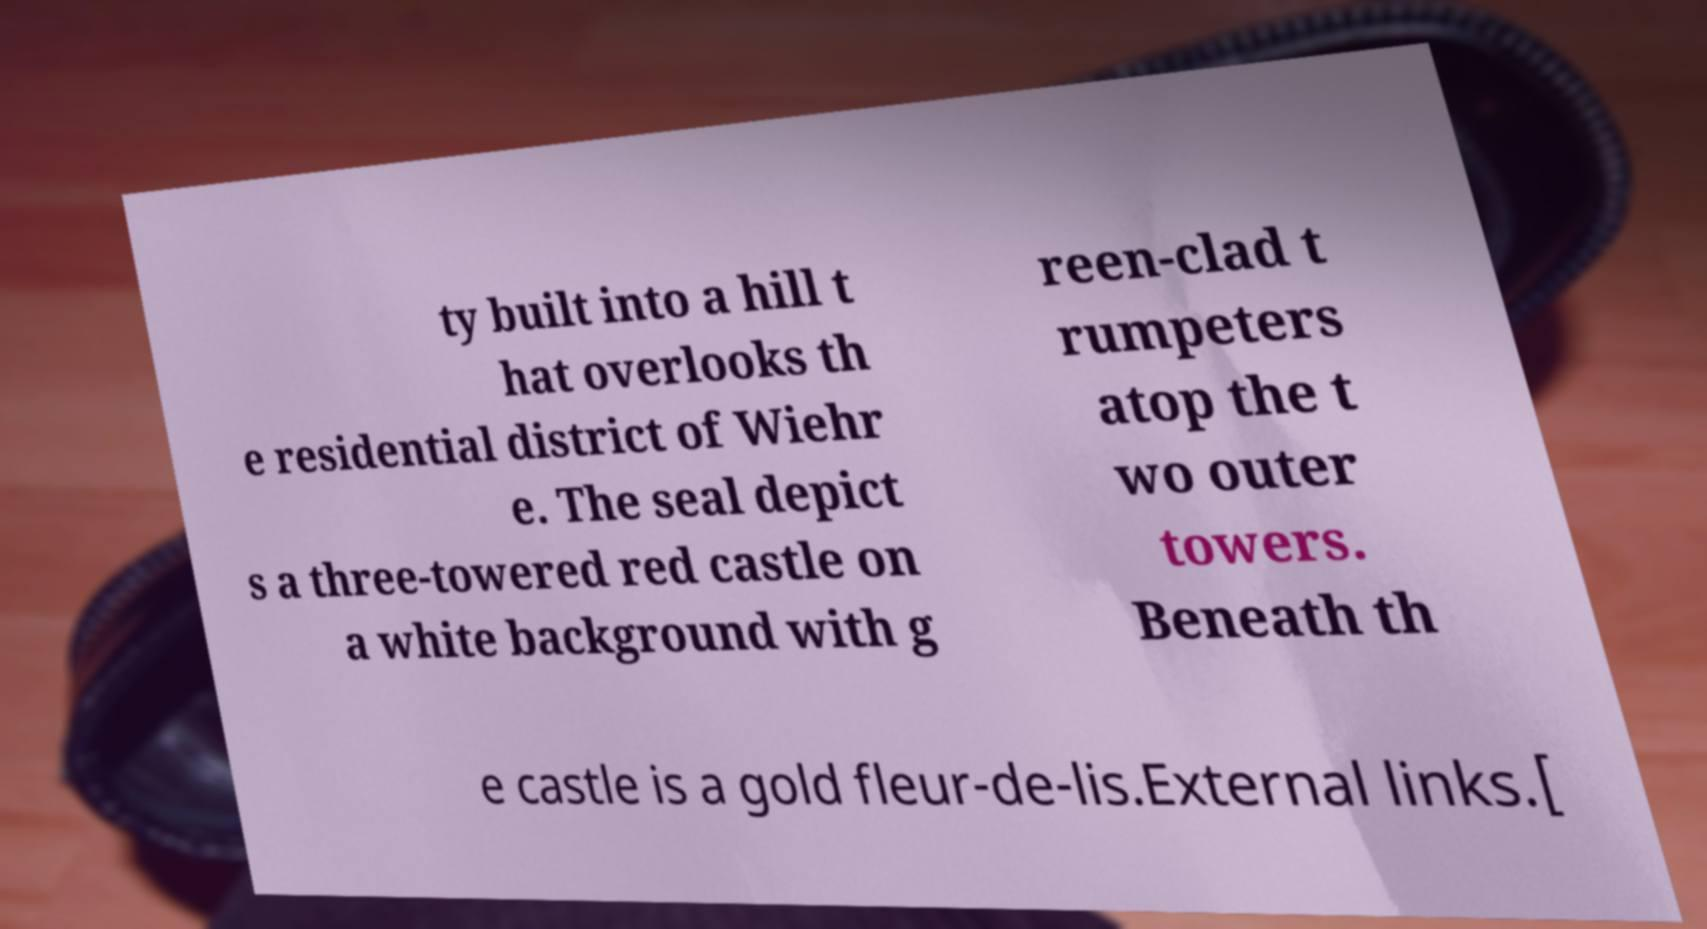Can you read and provide the text displayed in the image?This photo seems to have some interesting text. Can you extract and type it out for me? ty built into a hill t hat overlooks th e residential district of Wiehr e. The seal depict s a three-towered red castle on a white background with g reen-clad t rumpeters atop the t wo outer towers. Beneath th e castle is a gold fleur-de-lis.External links.[ 